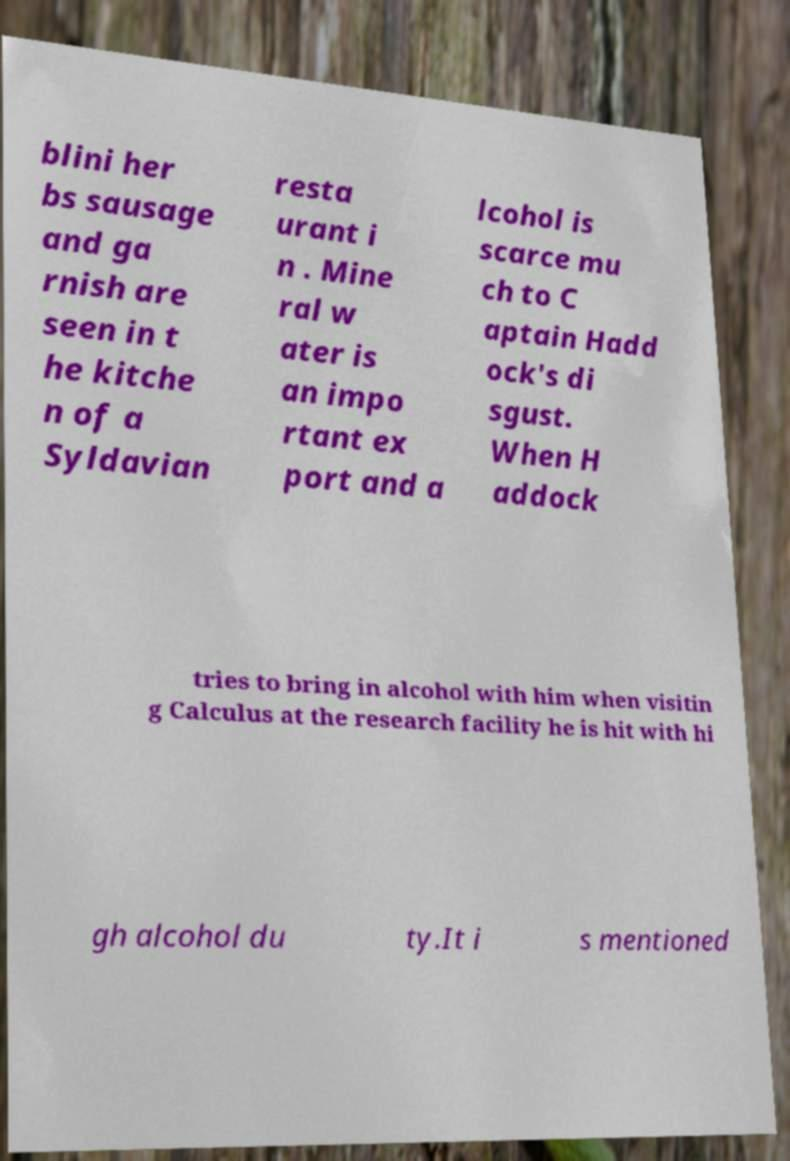Please identify and transcribe the text found in this image. blini her bs sausage and ga rnish are seen in t he kitche n of a Syldavian resta urant i n . Mine ral w ater is an impo rtant ex port and a lcohol is scarce mu ch to C aptain Hadd ock's di sgust. When H addock tries to bring in alcohol with him when visitin g Calculus at the research facility he is hit with hi gh alcohol du ty.It i s mentioned 